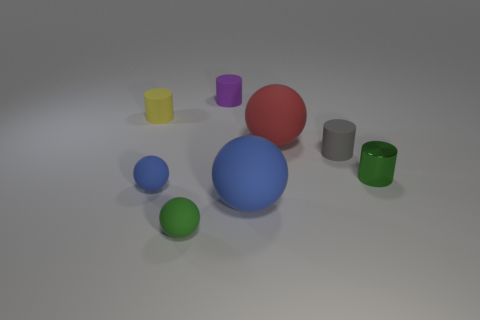Are there any other things that have the same material as the green cylinder?
Your answer should be very brief. No. There is a small green object right of the tiny green object in front of the big rubber sphere to the left of the red rubber ball; what is it made of?
Make the answer very short. Metal. Are there any cylinders that have the same size as the gray thing?
Offer a terse response. Yes. What is the shape of the tiny gray thing?
Offer a very short reply. Cylinder. How many cubes are either big red matte objects or small green rubber things?
Your answer should be very brief. 0. Is the number of yellow rubber cylinders in front of the big red matte thing the same as the number of purple cylinders that are behind the gray thing?
Provide a short and direct response. No. There is a large sphere that is in front of the tiny green object that is right of the tiny purple rubber thing; what number of gray rubber things are behind it?
Ensure brevity in your answer.  1. There is a shiny cylinder; is it the same color as the small matte sphere on the right side of the tiny blue ball?
Keep it short and to the point. Yes. Is the number of matte spheres in front of the big red thing greater than the number of yellow rubber cylinders?
Offer a terse response. Yes. What number of objects are large rubber spheres in front of the red rubber sphere or rubber objects that are in front of the tiny green shiny object?
Ensure brevity in your answer.  3. 